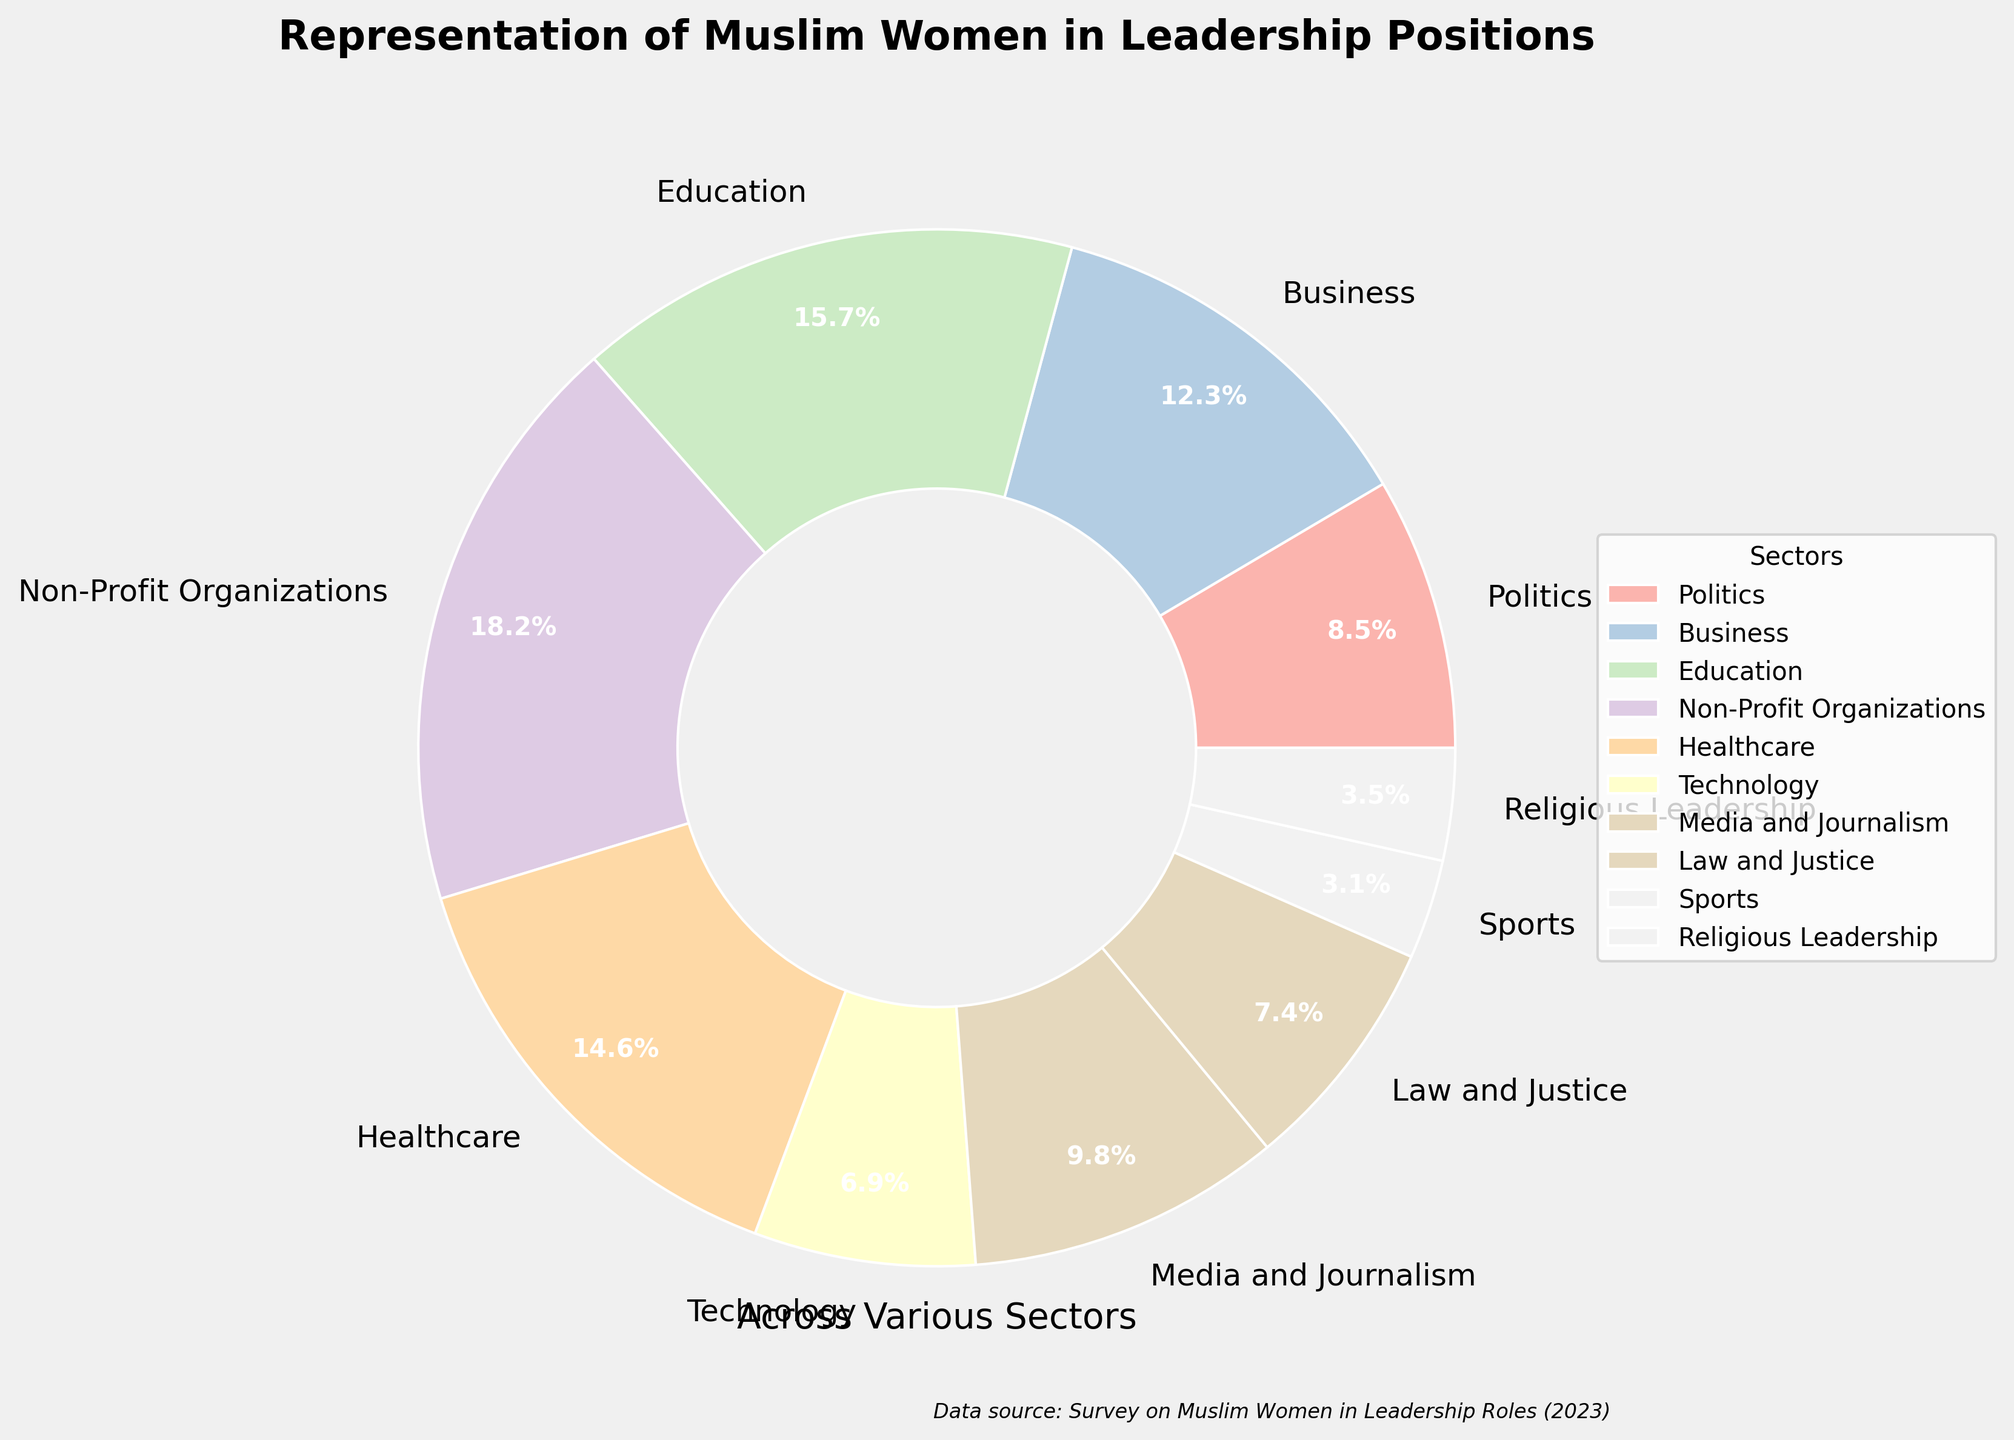What sector has the highest representation of Muslim women in leadership positions? According to the figure, Non-Profit Organizations have the highest representation with 18.2%. This sector’s portion of the pie chart is the largest.
Answer: Non-Profit Organizations Which sector has the lowest representation? By examining the smallest segment of the pie chart, it's clear that the Sports sector has the lowest representation at 3.1%.
Answer: Sports What is the total percentage of Muslim women in leadership positions in the Education and Healthcare sectors combined? The percentage for the Education sector is 15.7%, and for Healthcare, it's 14.6%. Adding them together: 15.7 + 14.6 = 30.3%.
Answer: 30.3% Which has a higher representation: Law and Justice or Media and Journalism, and by how much? The share for Law and Justice is 7.4%, and for Media and Journalism, it is 9.8%. Subtraction shows: 9.8 - 7.4 = 2.4%. Media and Journalism has a higher representation by 2.4%.
Answer: Media and Journalism by 2.4% How much greater is the percentage of Muslim women in leadership positions in Business compared to Technology? The Business sector shows 12.3%, while Technology shows 6.9%. The difference is found by subtracting: 12.3 - 6.9 = 5.4%.
Answer: 5.4% What percentage of sectors have less than 10% representation? Sectors with less than 10% are: Politics (8.5%), Technology (6.9%), Media and Journalism (9.8%), Law and Justice (7.4%), Sports (3.1%), and Religious Leadership (3.5%). Counting these gives 6 sectors out of 10, thus 60%.
Answer: 60% What is the percentage difference between the sector with the highest and the sector with the lowest representation? The highest representation is Non-Profit Organizations at 18.2%, and the lowest is Sports at 3.1%. The difference is: 18.2 - 3.1 = 15.1%.
Answer: 15.1% Which sector has a representation closest to 10%? By examining the pie chart, Media and Journalism at 9.8% is the closest to 10%.
Answer: Media and Journalism How does the representation of Muslim women in Business compare to that in Politics? Representation in Business is 12.3%, while in Politics, it is 8.5%. 12.3% is greater than 8.5%.
Answer: Business Which sectors have a representation below the median percentage? First, arrange the percentages in ascending order: 3.1%, 3.5%, 6.9%, 7.4%, 8.5%, 9.8%, 12.3%, 14.6%, 15.7%, 18.2%. With 10 sectors, the median is the average of the 5th and 6th values: (8.5 + 9.8)/2 = 9.15%. Sectors under 9.15% are Politics, Technology, Law and Justice, Sports, and Religious Leadership.
Answer: Politics, Technology, Law and Justice, Sports, Religious Leadership 